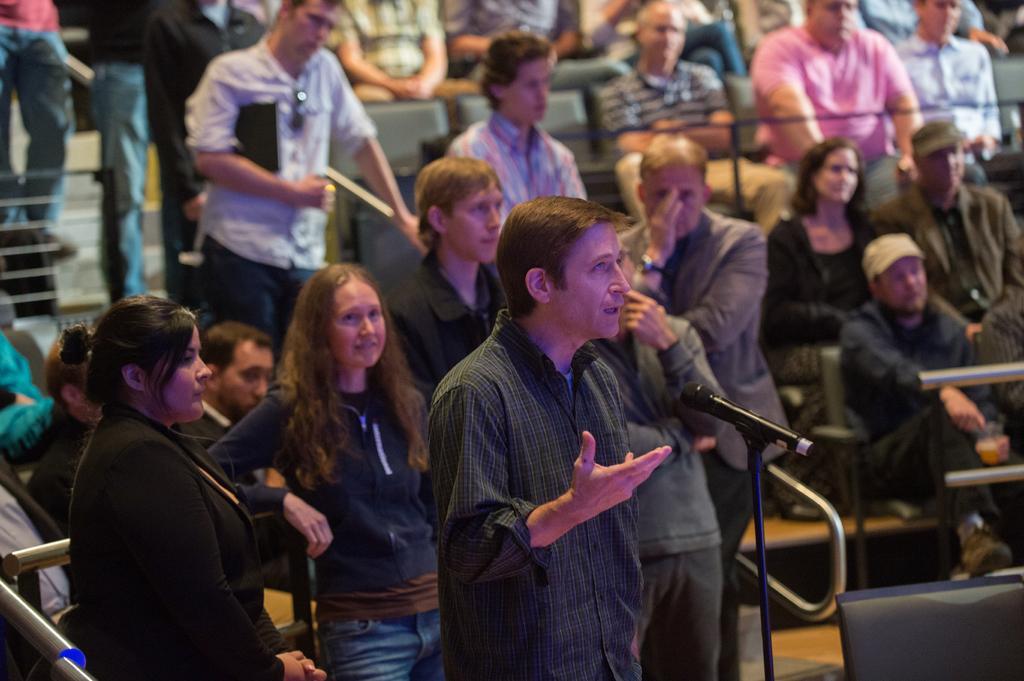Describe this image in one or two sentences. In this image we can see some people standing on the stairs and some are sitting on the chairs. Of them one is speaking to the mic placed in front on the floor. 